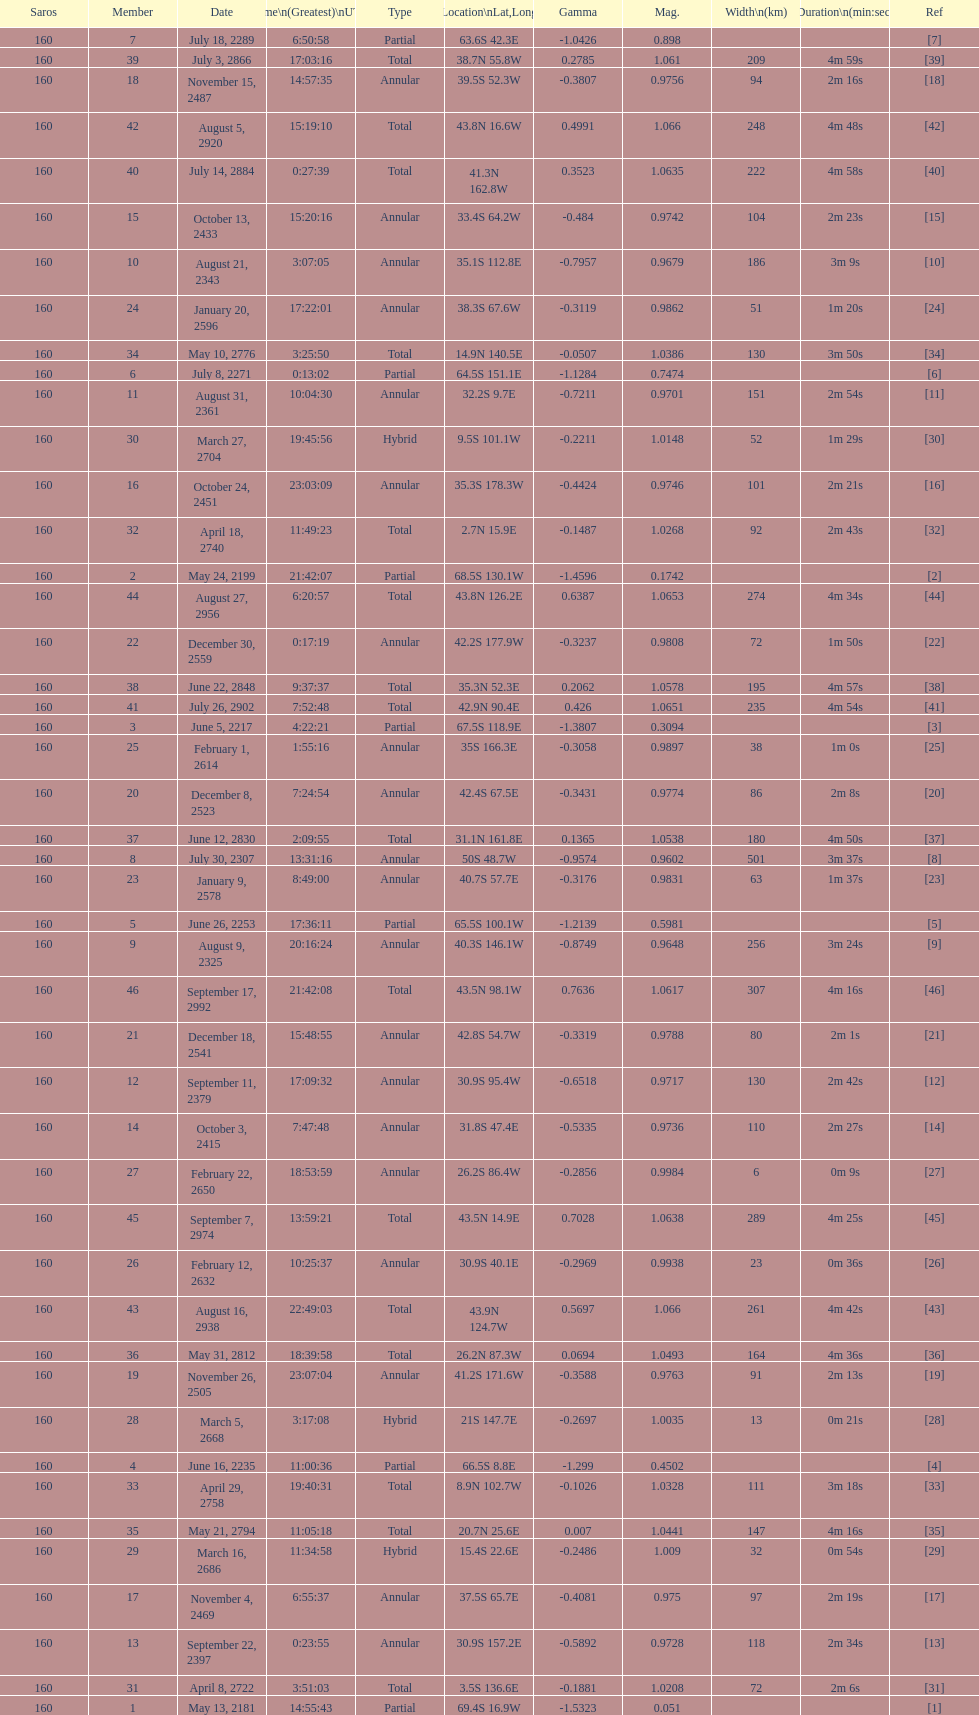How long did the the saros on july 30, 2307 last for? 3m 37s. 